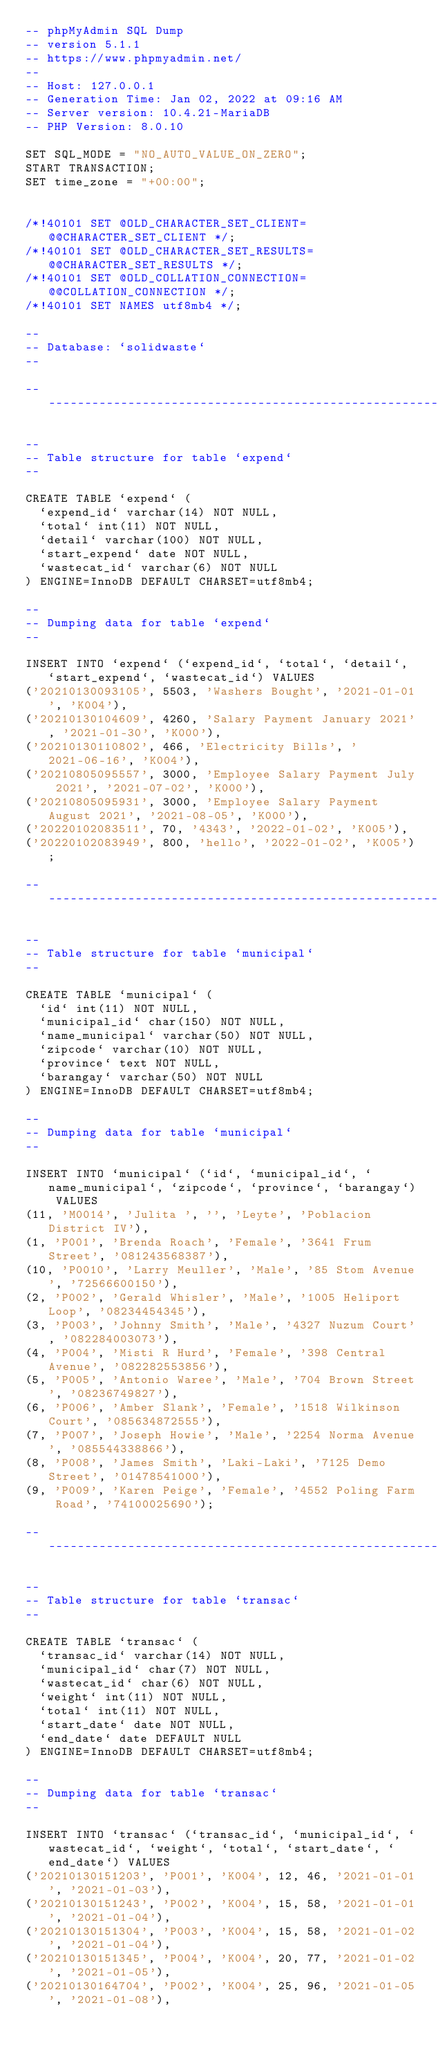Convert code to text. <code><loc_0><loc_0><loc_500><loc_500><_SQL_>-- phpMyAdmin SQL Dump
-- version 5.1.1
-- https://www.phpmyadmin.net/
--
-- Host: 127.0.0.1
-- Generation Time: Jan 02, 2022 at 09:16 AM
-- Server version: 10.4.21-MariaDB
-- PHP Version: 8.0.10

SET SQL_MODE = "NO_AUTO_VALUE_ON_ZERO";
START TRANSACTION;
SET time_zone = "+00:00";


/*!40101 SET @OLD_CHARACTER_SET_CLIENT=@@CHARACTER_SET_CLIENT */;
/*!40101 SET @OLD_CHARACTER_SET_RESULTS=@@CHARACTER_SET_RESULTS */;
/*!40101 SET @OLD_COLLATION_CONNECTION=@@COLLATION_CONNECTION */;
/*!40101 SET NAMES utf8mb4 */;

--
-- Database: `solidwaste`
--

-- --------------------------------------------------------

--
-- Table structure for table `expend`
--

CREATE TABLE `expend` (
  `expend_id` varchar(14) NOT NULL,
  `total` int(11) NOT NULL,
  `detail` varchar(100) NOT NULL,
  `start_expend` date NOT NULL,
  `wastecat_id` varchar(6) NOT NULL
) ENGINE=InnoDB DEFAULT CHARSET=utf8mb4;

--
-- Dumping data for table `expend`
--

INSERT INTO `expend` (`expend_id`, `total`, `detail`, `start_expend`, `wastecat_id`) VALUES
('20210130093105', 5503, 'Washers Bought', '2021-01-01', 'K004'),
('20210130104609', 4260, 'Salary Payment January 2021', '2021-01-30', 'K000'),
('20210130110802', 466, 'Electricity Bills', '2021-06-16', 'K004'),
('20210805095557', 3000, 'Employee Salary Payment July 2021', '2021-07-02', 'K000'),
('20210805095931', 3000, 'Employee Salary Payment August 2021', '2021-08-05', 'K000'),
('20220102083511', 70, '4343', '2022-01-02', 'K005'),
('20220102083949', 800, 'hello', '2022-01-02', 'K005');

-- --------------------------------------------------------

--
-- Table structure for table `municipal`
--

CREATE TABLE `municipal` (
  `id` int(11) NOT NULL,
  `municipal_id` char(150) NOT NULL,
  `name_municipal` varchar(50) NOT NULL,
  `zipcode` varchar(10) NOT NULL,
  `province` text NOT NULL,
  `barangay` varchar(50) NOT NULL
) ENGINE=InnoDB DEFAULT CHARSET=utf8mb4;

--
-- Dumping data for table `municipal`
--

INSERT INTO `municipal` (`id`, `municipal_id`, `name_municipal`, `zipcode`, `province`, `barangay`) VALUES
(11, 'M0014', 'Julita ', '', 'Leyte', 'Poblacion District IV'),
(1, 'P001', 'Brenda Roach', 'Female', '3641 Frum Street', '081243568387'),
(10, 'P0010', 'Larry Meuller', 'Male', '85 Stom Avenue', '72566600150'),
(2, 'P002', 'Gerald Whisler', 'Male', '1005 Heliport Loop', '08234454345'),
(3, 'P003', 'Johnny Smith', 'Male', '4327 Nuzum Court', '082284003073'),
(4, 'P004', 'Misti R Hurd', 'Female', '398 Central Avenue', '082282553856'),
(5, 'P005', 'Antonio Waree', 'Male', '704 Brown Street', '08236749827'),
(6, 'P006', 'Amber Slank', 'Female', '1518 Wilkinson Court', '085634872555'),
(7, 'P007', 'Joseph Howie', 'Male', '2254 Norma Avenue', '085544338866'),
(8, 'P008', 'James Smith', 'Laki-Laki', '7125 Demo Street', '01478541000'),
(9, 'P009', 'Karen Peige', 'Female', '4552 Poling Farm Road', '74100025690');

-- --------------------------------------------------------

--
-- Table structure for table `transac`
--

CREATE TABLE `transac` (
  `transac_id` varchar(14) NOT NULL,
  `municipal_id` char(7) NOT NULL,
  `wastecat_id` char(6) NOT NULL,
  `weight` int(11) NOT NULL,
  `total` int(11) NOT NULL,
  `start_date` date NOT NULL,
  `end_date` date DEFAULT NULL
) ENGINE=InnoDB DEFAULT CHARSET=utf8mb4;

--
-- Dumping data for table `transac`
--

INSERT INTO `transac` (`transac_id`, `municipal_id`, `wastecat_id`, `weight`, `total`, `start_date`, `end_date`) VALUES
('20210130151203', 'P001', 'K004', 12, 46, '2021-01-01', '2021-01-03'),
('20210130151243', 'P002', 'K004', 15, 58, '2021-01-01', '2021-01-04'),
('20210130151304', 'P003', 'K004', 15, 58, '2021-01-02', '2021-01-04'),
('20210130151345', 'P004', 'K004', 20, 77, '2021-01-02', '2021-01-05'),
('20210130164704', 'P002', 'K004', 25, 96, '2021-01-05', '2021-01-08'),</code> 